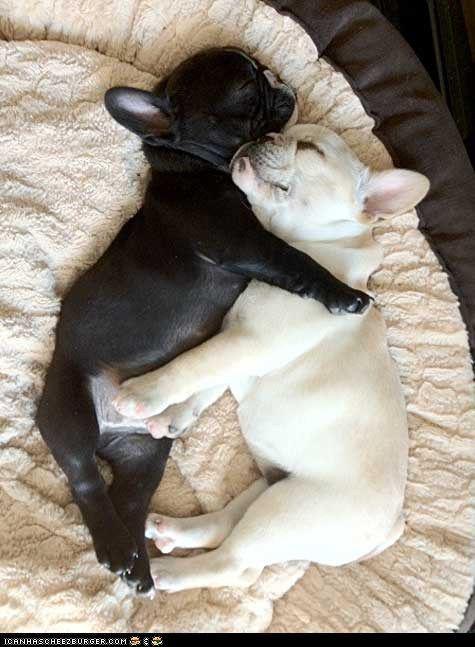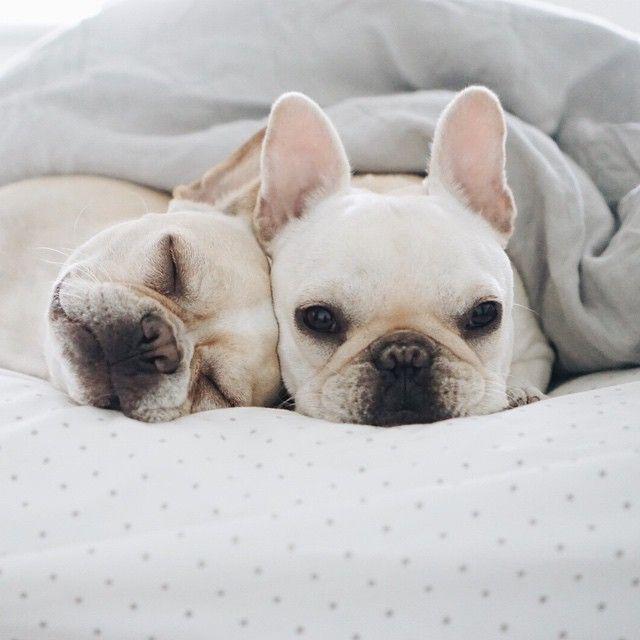The first image is the image on the left, the second image is the image on the right. Analyze the images presented: Is the assertion "There is at least one black french bulldog that is hugging a white dog." valid? Answer yes or no. Yes. The first image is the image on the left, the second image is the image on the right. For the images displayed, is the sentence "An image contains one black puppy with its front paws around one white puppy." factually correct? Answer yes or no. Yes. 